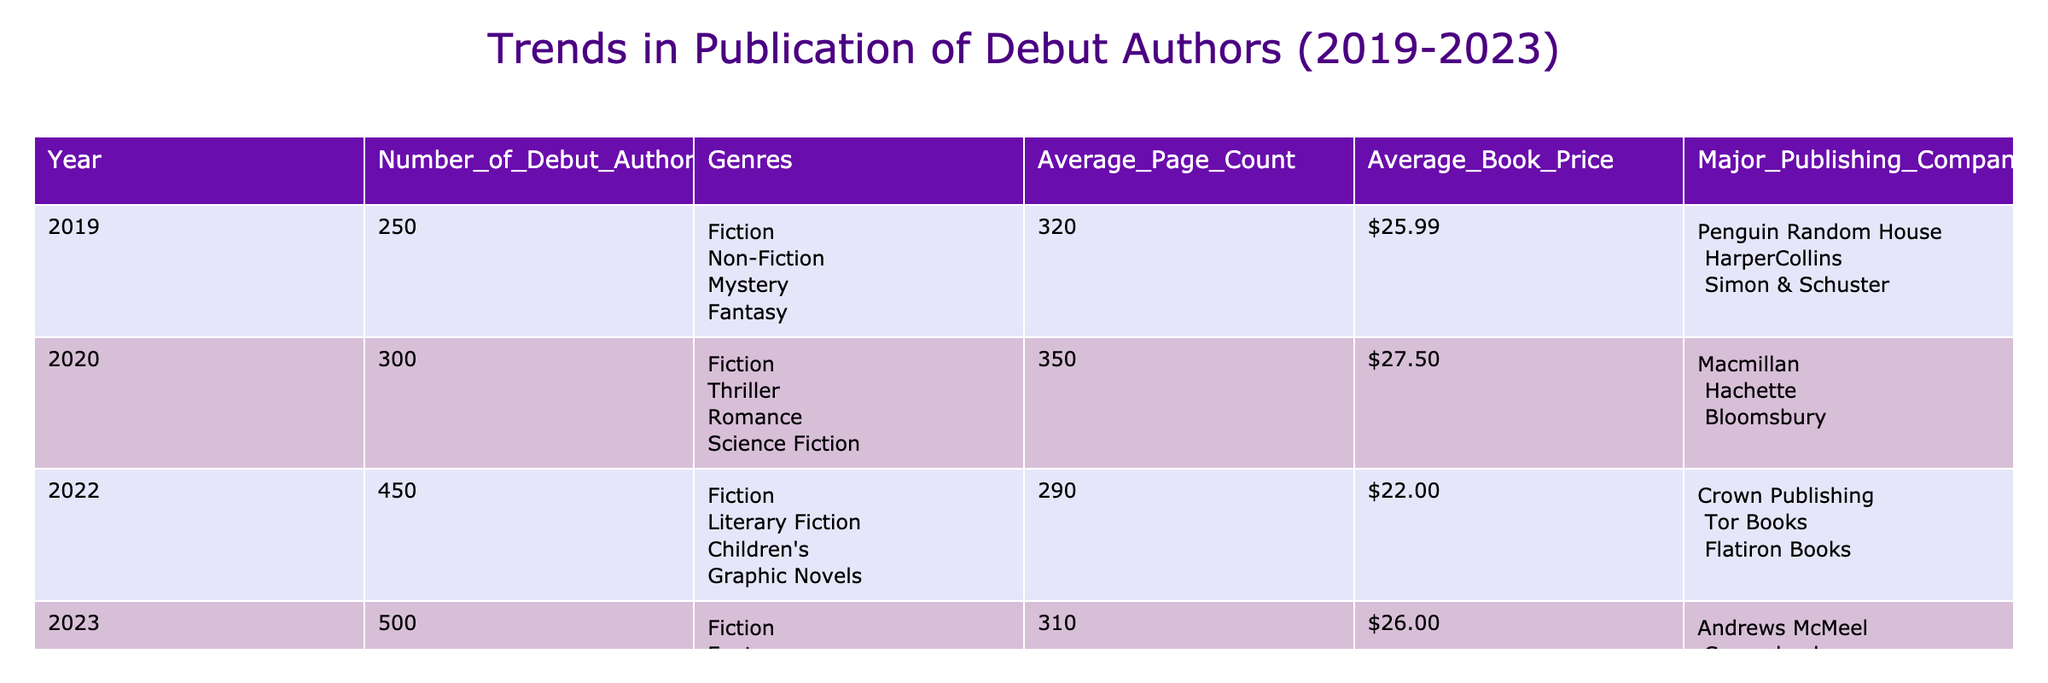What was the average book price for debut authors in 2021? The table does not provide data for the year 2021; therefore, this question cannot be answered.
Answer: Data not available Which year had the highest number of debut authors? Looking at the "Number of Debut Authors" column, 2023 has the highest value at 500.
Answer: 2023 What are the total number of debut authors published from 2019 to 2023? By adding the values from the "Number of Debut Authors" column: 250 + 300 + 450 + 500 = 1500.
Answer: 1500 Is the average book price for debut authors rising over the years? Comparing the average book prices from 2019 ($25.99) to 2023 ($26.00), the prices are slightly increasing; thus, we can say yes.
Answer: Yes How many different genres were represented in 2022? In the "Genres" column for 2022, four genres are listed: Literary Fiction, Children's, Graphic Novels, and Fiction.
Answer: 4 What was the lowest average page count recorded during these years? The average page counts for each year are as follows: 2019 (320), 2020 (350), 2022 (290), 2023 (310). The lowest average page count is from 2022, which is 290.
Answer: 290 Which year showed the greatest diversity in genres? In 2023, the genres listed include Fiction, Fantasy, Horror, and Self-Help—four different genres, which is more than any other year.
Answer: 2023 Is it true that 2020 had a higher average book price than 2023? The average book price in 2020 is $27.50, which is higher than the average book price in 2023, which is $26.00. Therefore, the statement is true.
Answer: True What is the average page count of debut authors across all the years listed? The average can be calculated by summing the page counts: (320 + 350 + 290 + 310) / 4 = 317.5. The average page count is thus 317.5.
Answer: 317.5 